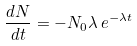<formula> <loc_0><loc_0><loc_500><loc_500>\frac { d N } { d t } = - N _ { 0 } \lambda \, e ^ { - { \lambda } t }</formula> 